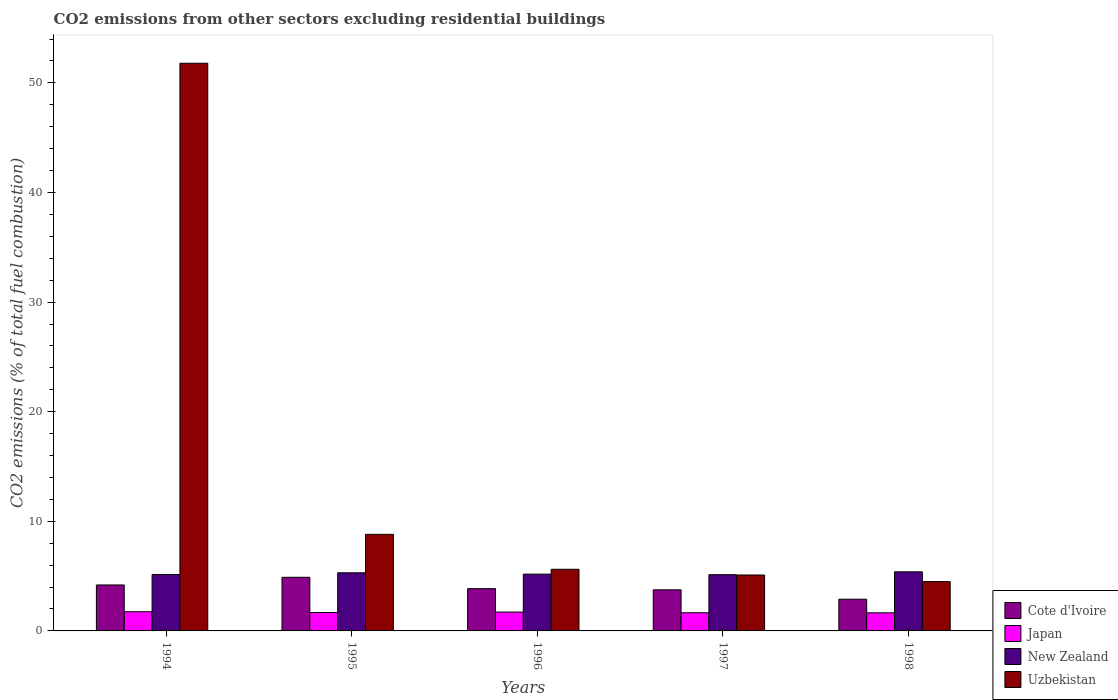How many groups of bars are there?
Give a very brief answer. 5. What is the label of the 1st group of bars from the left?
Your answer should be compact. 1994. What is the total CO2 emitted in Japan in 1995?
Offer a terse response. 1.68. Across all years, what is the maximum total CO2 emitted in Japan?
Offer a terse response. 1.75. Across all years, what is the minimum total CO2 emitted in Cote d'Ivoire?
Your response must be concise. 2.89. In which year was the total CO2 emitted in Japan maximum?
Offer a very short reply. 1994. What is the total total CO2 emitted in Cote d'Ivoire in the graph?
Make the answer very short. 19.59. What is the difference between the total CO2 emitted in Cote d'Ivoire in 1996 and that in 1997?
Your answer should be compact. 0.11. What is the difference between the total CO2 emitted in Cote d'Ivoire in 1998 and the total CO2 emitted in New Zealand in 1995?
Your answer should be very brief. -2.41. What is the average total CO2 emitted in Cote d'Ivoire per year?
Provide a short and direct response. 3.92. In the year 1994, what is the difference between the total CO2 emitted in New Zealand and total CO2 emitted in Uzbekistan?
Give a very brief answer. -46.64. In how many years, is the total CO2 emitted in New Zealand greater than 8?
Provide a succinct answer. 0. What is the ratio of the total CO2 emitted in New Zealand in 1994 to that in 1997?
Offer a terse response. 1. Is the difference between the total CO2 emitted in New Zealand in 1994 and 1998 greater than the difference between the total CO2 emitted in Uzbekistan in 1994 and 1998?
Keep it short and to the point. No. What is the difference between the highest and the second highest total CO2 emitted in Uzbekistan?
Keep it short and to the point. 42.98. What is the difference between the highest and the lowest total CO2 emitted in Japan?
Provide a succinct answer. 0.1. In how many years, is the total CO2 emitted in Cote d'Ivoire greater than the average total CO2 emitted in Cote d'Ivoire taken over all years?
Give a very brief answer. 2. Is the sum of the total CO2 emitted in New Zealand in 1994 and 1995 greater than the maximum total CO2 emitted in Cote d'Ivoire across all years?
Your answer should be compact. Yes. Is it the case that in every year, the sum of the total CO2 emitted in Japan and total CO2 emitted in New Zealand is greater than the sum of total CO2 emitted in Uzbekistan and total CO2 emitted in Cote d'Ivoire?
Your answer should be very brief. No. What does the 4th bar from the left in 1998 represents?
Your answer should be compact. Uzbekistan. What does the 1st bar from the right in 1994 represents?
Offer a terse response. Uzbekistan. Is it the case that in every year, the sum of the total CO2 emitted in Cote d'Ivoire and total CO2 emitted in Japan is greater than the total CO2 emitted in Uzbekistan?
Ensure brevity in your answer.  No. Are all the bars in the graph horizontal?
Make the answer very short. No. What is the difference between two consecutive major ticks on the Y-axis?
Offer a terse response. 10. Does the graph contain any zero values?
Provide a succinct answer. No. What is the title of the graph?
Provide a short and direct response. CO2 emissions from other sectors excluding residential buildings. Does "Sub-Saharan Africa (developing only)" appear as one of the legend labels in the graph?
Your answer should be compact. No. What is the label or title of the X-axis?
Offer a terse response. Years. What is the label or title of the Y-axis?
Offer a very short reply. CO2 emissions (% of total fuel combustion). What is the CO2 emissions (% of total fuel combustion) of Cote d'Ivoire in 1994?
Make the answer very short. 4.19. What is the CO2 emissions (% of total fuel combustion) in Japan in 1994?
Your response must be concise. 1.75. What is the CO2 emissions (% of total fuel combustion) in New Zealand in 1994?
Provide a succinct answer. 5.15. What is the CO2 emissions (% of total fuel combustion) of Uzbekistan in 1994?
Give a very brief answer. 51.79. What is the CO2 emissions (% of total fuel combustion) of Cote d'Ivoire in 1995?
Your answer should be very brief. 4.89. What is the CO2 emissions (% of total fuel combustion) of Japan in 1995?
Ensure brevity in your answer.  1.68. What is the CO2 emissions (% of total fuel combustion) in New Zealand in 1995?
Ensure brevity in your answer.  5.3. What is the CO2 emissions (% of total fuel combustion) in Uzbekistan in 1995?
Offer a very short reply. 8.81. What is the CO2 emissions (% of total fuel combustion) of Cote d'Ivoire in 1996?
Keep it short and to the point. 3.86. What is the CO2 emissions (% of total fuel combustion) of Japan in 1996?
Your response must be concise. 1.72. What is the CO2 emissions (% of total fuel combustion) of New Zealand in 1996?
Provide a short and direct response. 5.18. What is the CO2 emissions (% of total fuel combustion) in Uzbekistan in 1996?
Your response must be concise. 5.62. What is the CO2 emissions (% of total fuel combustion) in Cote d'Ivoire in 1997?
Your response must be concise. 3.75. What is the CO2 emissions (% of total fuel combustion) in Japan in 1997?
Provide a succinct answer. 1.66. What is the CO2 emissions (% of total fuel combustion) of New Zealand in 1997?
Give a very brief answer. 5.13. What is the CO2 emissions (% of total fuel combustion) of Uzbekistan in 1997?
Make the answer very short. 5.1. What is the CO2 emissions (% of total fuel combustion) in Cote d'Ivoire in 1998?
Your answer should be compact. 2.89. What is the CO2 emissions (% of total fuel combustion) in Japan in 1998?
Keep it short and to the point. 1.65. What is the CO2 emissions (% of total fuel combustion) of New Zealand in 1998?
Your answer should be very brief. 5.39. What is the CO2 emissions (% of total fuel combustion) of Uzbekistan in 1998?
Give a very brief answer. 4.5. Across all years, what is the maximum CO2 emissions (% of total fuel combustion) in Cote d'Ivoire?
Provide a short and direct response. 4.89. Across all years, what is the maximum CO2 emissions (% of total fuel combustion) in Japan?
Your answer should be very brief. 1.75. Across all years, what is the maximum CO2 emissions (% of total fuel combustion) of New Zealand?
Give a very brief answer. 5.39. Across all years, what is the maximum CO2 emissions (% of total fuel combustion) of Uzbekistan?
Provide a succinct answer. 51.79. Across all years, what is the minimum CO2 emissions (% of total fuel combustion) of Cote d'Ivoire?
Your response must be concise. 2.89. Across all years, what is the minimum CO2 emissions (% of total fuel combustion) in Japan?
Keep it short and to the point. 1.65. Across all years, what is the minimum CO2 emissions (% of total fuel combustion) in New Zealand?
Ensure brevity in your answer.  5.13. Across all years, what is the minimum CO2 emissions (% of total fuel combustion) in Uzbekistan?
Make the answer very short. 4.5. What is the total CO2 emissions (% of total fuel combustion) of Cote d'Ivoire in the graph?
Your response must be concise. 19.59. What is the total CO2 emissions (% of total fuel combustion) of Japan in the graph?
Your response must be concise. 8.45. What is the total CO2 emissions (% of total fuel combustion) in New Zealand in the graph?
Your response must be concise. 26.15. What is the total CO2 emissions (% of total fuel combustion) of Uzbekistan in the graph?
Keep it short and to the point. 75.82. What is the difference between the CO2 emissions (% of total fuel combustion) in Cote d'Ivoire in 1994 and that in 1995?
Ensure brevity in your answer.  -0.7. What is the difference between the CO2 emissions (% of total fuel combustion) in Japan in 1994 and that in 1995?
Offer a very short reply. 0.07. What is the difference between the CO2 emissions (% of total fuel combustion) in New Zealand in 1994 and that in 1995?
Give a very brief answer. -0.15. What is the difference between the CO2 emissions (% of total fuel combustion) in Uzbekistan in 1994 and that in 1995?
Your answer should be very brief. 42.98. What is the difference between the CO2 emissions (% of total fuel combustion) of Cote d'Ivoire in 1994 and that in 1996?
Make the answer very short. 0.34. What is the difference between the CO2 emissions (% of total fuel combustion) in Japan in 1994 and that in 1996?
Offer a terse response. 0.03. What is the difference between the CO2 emissions (% of total fuel combustion) of New Zealand in 1994 and that in 1996?
Ensure brevity in your answer.  -0.03. What is the difference between the CO2 emissions (% of total fuel combustion) in Uzbekistan in 1994 and that in 1996?
Your answer should be very brief. 46.16. What is the difference between the CO2 emissions (% of total fuel combustion) in Cote d'Ivoire in 1994 and that in 1997?
Ensure brevity in your answer.  0.44. What is the difference between the CO2 emissions (% of total fuel combustion) of Japan in 1994 and that in 1997?
Offer a terse response. 0.09. What is the difference between the CO2 emissions (% of total fuel combustion) in New Zealand in 1994 and that in 1997?
Offer a very short reply. 0.02. What is the difference between the CO2 emissions (% of total fuel combustion) in Uzbekistan in 1994 and that in 1997?
Your answer should be very brief. 46.69. What is the difference between the CO2 emissions (% of total fuel combustion) in Cote d'Ivoire in 1994 and that in 1998?
Make the answer very short. 1.3. What is the difference between the CO2 emissions (% of total fuel combustion) in Japan in 1994 and that in 1998?
Make the answer very short. 0.1. What is the difference between the CO2 emissions (% of total fuel combustion) of New Zealand in 1994 and that in 1998?
Make the answer very short. -0.24. What is the difference between the CO2 emissions (% of total fuel combustion) in Uzbekistan in 1994 and that in 1998?
Ensure brevity in your answer.  47.29. What is the difference between the CO2 emissions (% of total fuel combustion) of Cote d'Ivoire in 1995 and that in 1996?
Your answer should be compact. 1.04. What is the difference between the CO2 emissions (% of total fuel combustion) of Japan in 1995 and that in 1996?
Give a very brief answer. -0.04. What is the difference between the CO2 emissions (% of total fuel combustion) in New Zealand in 1995 and that in 1996?
Offer a very short reply. 0.12. What is the difference between the CO2 emissions (% of total fuel combustion) in Uzbekistan in 1995 and that in 1996?
Your answer should be compact. 3.19. What is the difference between the CO2 emissions (% of total fuel combustion) of Cote d'Ivoire in 1995 and that in 1997?
Offer a terse response. 1.14. What is the difference between the CO2 emissions (% of total fuel combustion) of Japan in 1995 and that in 1997?
Your answer should be compact. 0.02. What is the difference between the CO2 emissions (% of total fuel combustion) in New Zealand in 1995 and that in 1997?
Keep it short and to the point. 0.17. What is the difference between the CO2 emissions (% of total fuel combustion) of Uzbekistan in 1995 and that in 1997?
Make the answer very short. 3.71. What is the difference between the CO2 emissions (% of total fuel combustion) in Cote d'Ivoire in 1995 and that in 1998?
Your answer should be very brief. 2. What is the difference between the CO2 emissions (% of total fuel combustion) of Japan in 1995 and that in 1998?
Your answer should be compact. 0.03. What is the difference between the CO2 emissions (% of total fuel combustion) in New Zealand in 1995 and that in 1998?
Offer a terse response. -0.09. What is the difference between the CO2 emissions (% of total fuel combustion) of Uzbekistan in 1995 and that in 1998?
Your answer should be very brief. 4.31. What is the difference between the CO2 emissions (% of total fuel combustion) of Cote d'Ivoire in 1996 and that in 1997?
Provide a succinct answer. 0.11. What is the difference between the CO2 emissions (% of total fuel combustion) in Japan in 1996 and that in 1997?
Your response must be concise. 0.06. What is the difference between the CO2 emissions (% of total fuel combustion) in New Zealand in 1996 and that in 1997?
Ensure brevity in your answer.  0.05. What is the difference between the CO2 emissions (% of total fuel combustion) in Uzbekistan in 1996 and that in 1997?
Make the answer very short. 0.52. What is the difference between the CO2 emissions (% of total fuel combustion) of Cote d'Ivoire in 1996 and that in 1998?
Your response must be concise. 0.96. What is the difference between the CO2 emissions (% of total fuel combustion) of Japan in 1996 and that in 1998?
Make the answer very short. 0.07. What is the difference between the CO2 emissions (% of total fuel combustion) in New Zealand in 1996 and that in 1998?
Ensure brevity in your answer.  -0.21. What is the difference between the CO2 emissions (% of total fuel combustion) of Uzbekistan in 1996 and that in 1998?
Provide a short and direct response. 1.12. What is the difference between the CO2 emissions (% of total fuel combustion) of Cote d'Ivoire in 1997 and that in 1998?
Provide a short and direct response. 0.86. What is the difference between the CO2 emissions (% of total fuel combustion) in Japan in 1997 and that in 1998?
Your response must be concise. 0. What is the difference between the CO2 emissions (% of total fuel combustion) of New Zealand in 1997 and that in 1998?
Your answer should be compact. -0.26. What is the difference between the CO2 emissions (% of total fuel combustion) in Uzbekistan in 1997 and that in 1998?
Keep it short and to the point. 0.6. What is the difference between the CO2 emissions (% of total fuel combustion) of Cote d'Ivoire in 1994 and the CO2 emissions (% of total fuel combustion) of Japan in 1995?
Provide a short and direct response. 2.52. What is the difference between the CO2 emissions (% of total fuel combustion) in Cote d'Ivoire in 1994 and the CO2 emissions (% of total fuel combustion) in New Zealand in 1995?
Your response must be concise. -1.11. What is the difference between the CO2 emissions (% of total fuel combustion) in Cote d'Ivoire in 1994 and the CO2 emissions (% of total fuel combustion) in Uzbekistan in 1995?
Ensure brevity in your answer.  -4.62. What is the difference between the CO2 emissions (% of total fuel combustion) in Japan in 1994 and the CO2 emissions (% of total fuel combustion) in New Zealand in 1995?
Your response must be concise. -3.55. What is the difference between the CO2 emissions (% of total fuel combustion) in Japan in 1994 and the CO2 emissions (% of total fuel combustion) in Uzbekistan in 1995?
Give a very brief answer. -7.06. What is the difference between the CO2 emissions (% of total fuel combustion) of New Zealand in 1994 and the CO2 emissions (% of total fuel combustion) of Uzbekistan in 1995?
Offer a very short reply. -3.66. What is the difference between the CO2 emissions (% of total fuel combustion) in Cote d'Ivoire in 1994 and the CO2 emissions (% of total fuel combustion) in Japan in 1996?
Your answer should be compact. 2.48. What is the difference between the CO2 emissions (% of total fuel combustion) in Cote d'Ivoire in 1994 and the CO2 emissions (% of total fuel combustion) in New Zealand in 1996?
Make the answer very short. -0.99. What is the difference between the CO2 emissions (% of total fuel combustion) in Cote d'Ivoire in 1994 and the CO2 emissions (% of total fuel combustion) in Uzbekistan in 1996?
Offer a very short reply. -1.43. What is the difference between the CO2 emissions (% of total fuel combustion) of Japan in 1994 and the CO2 emissions (% of total fuel combustion) of New Zealand in 1996?
Give a very brief answer. -3.43. What is the difference between the CO2 emissions (% of total fuel combustion) in Japan in 1994 and the CO2 emissions (% of total fuel combustion) in Uzbekistan in 1996?
Your answer should be compact. -3.87. What is the difference between the CO2 emissions (% of total fuel combustion) of New Zealand in 1994 and the CO2 emissions (% of total fuel combustion) of Uzbekistan in 1996?
Make the answer very short. -0.47. What is the difference between the CO2 emissions (% of total fuel combustion) in Cote d'Ivoire in 1994 and the CO2 emissions (% of total fuel combustion) in Japan in 1997?
Provide a short and direct response. 2.54. What is the difference between the CO2 emissions (% of total fuel combustion) in Cote d'Ivoire in 1994 and the CO2 emissions (% of total fuel combustion) in New Zealand in 1997?
Keep it short and to the point. -0.94. What is the difference between the CO2 emissions (% of total fuel combustion) in Cote d'Ivoire in 1994 and the CO2 emissions (% of total fuel combustion) in Uzbekistan in 1997?
Make the answer very short. -0.91. What is the difference between the CO2 emissions (% of total fuel combustion) of Japan in 1994 and the CO2 emissions (% of total fuel combustion) of New Zealand in 1997?
Give a very brief answer. -3.38. What is the difference between the CO2 emissions (% of total fuel combustion) of Japan in 1994 and the CO2 emissions (% of total fuel combustion) of Uzbekistan in 1997?
Provide a succinct answer. -3.35. What is the difference between the CO2 emissions (% of total fuel combustion) of New Zealand in 1994 and the CO2 emissions (% of total fuel combustion) of Uzbekistan in 1997?
Keep it short and to the point. 0.05. What is the difference between the CO2 emissions (% of total fuel combustion) in Cote d'Ivoire in 1994 and the CO2 emissions (% of total fuel combustion) in Japan in 1998?
Your answer should be very brief. 2.54. What is the difference between the CO2 emissions (% of total fuel combustion) of Cote d'Ivoire in 1994 and the CO2 emissions (% of total fuel combustion) of New Zealand in 1998?
Keep it short and to the point. -1.2. What is the difference between the CO2 emissions (% of total fuel combustion) of Cote d'Ivoire in 1994 and the CO2 emissions (% of total fuel combustion) of Uzbekistan in 1998?
Ensure brevity in your answer.  -0.31. What is the difference between the CO2 emissions (% of total fuel combustion) of Japan in 1994 and the CO2 emissions (% of total fuel combustion) of New Zealand in 1998?
Provide a succinct answer. -3.64. What is the difference between the CO2 emissions (% of total fuel combustion) in Japan in 1994 and the CO2 emissions (% of total fuel combustion) in Uzbekistan in 1998?
Provide a succinct answer. -2.75. What is the difference between the CO2 emissions (% of total fuel combustion) in New Zealand in 1994 and the CO2 emissions (% of total fuel combustion) in Uzbekistan in 1998?
Your answer should be compact. 0.65. What is the difference between the CO2 emissions (% of total fuel combustion) of Cote d'Ivoire in 1995 and the CO2 emissions (% of total fuel combustion) of Japan in 1996?
Make the answer very short. 3.17. What is the difference between the CO2 emissions (% of total fuel combustion) of Cote d'Ivoire in 1995 and the CO2 emissions (% of total fuel combustion) of New Zealand in 1996?
Provide a succinct answer. -0.29. What is the difference between the CO2 emissions (% of total fuel combustion) of Cote d'Ivoire in 1995 and the CO2 emissions (% of total fuel combustion) of Uzbekistan in 1996?
Ensure brevity in your answer.  -0.73. What is the difference between the CO2 emissions (% of total fuel combustion) in Japan in 1995 and the CO2 emissions (% of total fuel combustion) in New Zealand in 1996?
Your response must be concise. -3.5. What is the difference between the CO2 emissions (% of total fuel combustion) of Japan in 1995 and the CO2 emissions (% of total fuel combustion) of Uzbekistan in 1996?
Your answer should be very brief. -3.95. What is the difference between the CO2 emissions (% of total fuel combustion) in New Zealand in 1995 and the CO2 emissions (% of total fuel combustion) in Uzbekistan in 1996?
Make the answer very short. -0.32. What is the difference between the CO2 emissions (% of total fuel combustion) in Cote d'Ivoire in 1995 and the CO2 emissions (% of total fuel combustion) in Japan in 1997?
Your response must be concise. 3.24. What is the difference between the CO2 emissions (% of total fuel combustion) in Cote d'Ivoire in 1995 and the CO2 emissions (% of total fuel combustion) in New Zealand in 1997?
Ensure brevity in your answer.  -0.24. What is the difference between the CO2 emissions (% of total fuel combustion) of Cote d'Ivoire in 1995 and the CO2 emissions (% of total fuel combustion) of Uzbekistan in 1997?
Offer a terse response. -0.21. What is the difference between the CO2 emissions (% of total fuel combustion) in Japan in 1995 and the CO2 emissions (% of total fuel combustion) in New Zealand in 1997?
Your answer should be compact. -3.45. What is the difference between the CO2 emissions (% of total fuel combustion) in Japan in 1995 and the CO2 emissions (% of total fuel combustion) in Uzbekistan in 1997?
Offer a terse response. -3.43. What is the difference between the CO2 emissions (% of total fuel combustion) of New Zealand in 1995 and the CO2 emissions (% of total fuel combustion) of Uzbekistan in 1997?
Keep it short and to the point. 0.2. What is the difference between the CO2 emissions (% of total fuel combustion) in Cote d'Ivoire in 1995 and the CO2 emissions (% of total fuel combustion) in Japan in 1998?
Keep it short and to the point. 3.24. What is the difference between the CO2 emissions (% of total fuel combustion) in Cote d'Ivoire in 1995 and the CO2 emissions (% of total fuel combustion) in New Zealand in 1998?
Offer a terse response. -0.5. What is the difference between the CO2 emissions (% of total fuel combustion) in Cote d'Ivoire in 1995 and the CO2 emissions (% of total fuel combustion) in Uzbekistan in 1998?
Your answer should be compact. 0.39. What is the difference between the CO2 emissions (% of total fuel combustion) in Japan in 1995 and the CO2 emissions (% of total fuel combustion) in New Zealand in 1998?
Give a very brief answer. -3.72. What is the difference between the CO2 emissions (% of total fuel combustion) in Japan in 1995 and the CO2 emissions (% of total fuel combustion) in Uzbekistan in 1998?
Give a very brief answer. -2.82. What is the difference between the CO2 emissions (% of total fuel combustion) in New Zealand in 1995 and the CO2 emissions (% of total fuel combustion) in Uzbekistan in 1998?
Ensure brevity in your answer.  0.8. What is the difference between the CO2 emissions (% of total fuel combustion) of Cote d'Ivoire in 1996 and the CO2 emissions (% of total fuel combustion) of New Zealand in 1997?
Provide a short and direct response. -1.27. What is the difference between the CO2 emissions (% of total fuel combustion) in Cote d'Ivoire in 1996 and the CO2 emissions (% of total fuel combustion) in Uzbekistan in 1997?
Provide a short and direct response. -1.25. What is the difference between the CO2 emissions (% of total fuel combustion) in Japan in 1996 and the CO2 emissions (% of total fuel combustion) in New Zealand in 1997?
Offer a very short reply. -3.41. What is the difference between the CO2 emissions (% of total fuel combustion) in Japan in 1996 and the CO2 emissions (% of total fuel combustion) in Uzbekistan in 1997?
Ensure brevity in your answer.  -3.38. What is the difference between the CO2 emissions (% of total fuel combustion) in New Zealand in 1996 and the CO2 emissions (% of total fuel combustion) in Uzbekistan in 1997?
Your answer should be compact. 0.08. What is the difference between the CO2 emissions (% of total fuel combustion) in Cote d'Ivoire in 1996 and the CO2 emissions (% of total fuel combustion) in Japan in 1998?
Your answer should be compact. 2.2. What is the difference between the CO2 emissions (% of total fuel combustion) in Cote d'Ivoire in 1996 and the CO2 emissions (% of total fuel combustion) in New Zealand in 1998?
Provide a succinct answer. -1.54. What is the difference between the CO2 emissions (% of total fuel combustion) of Cote d'Ivoire in 1996 and the CO2 emissions (% of total fuel combustion) of Uzbekistan in 1998?
Your answer should be very brief. -0.64. What is the difference between the CO2 emissions (% of total fuel combustion) of Japan in 1996 and the CO2 emissions (% of total fuel combustion) of New Zealand in 1998?
Make the answer very short. -3.67. What is the difference between the CO2 emissions (% of total fuel combustion) in Japan in 1996 and the CO2 emissions (% of total fuel combustion) in Uzbekistan in 1998?
Your response must be concise. -2.78. What is the difference between the CO2 emissions (% of total fuel combustion) of New Zealand in 1996 and the CO2 emissions (% of total fuel combustion) of Uzbekistan in 1998?
Give a very brief answer. 0.68. What is the difference between the CO2 emissions (% of total fuel combustion) of Cote d'Ivoire in 1997 and the CO2 emissions (% of total fuel combustion) of Japan in 1998?
Make the answer very short. 2.1. What is the difference between the CO2 emissions (% of total fuel combustion) in Cote d'Ivoire in 1997 and the CO2 emissions (% of total fuel combustion) in New Zealand in 1998?
Offer a very short reply. -1.64. What is the difference between the CO2 emissions (% of total fuel combustion) in Cote d'Ivoire in 1997 and the CO2 emissions (% of total fuel combustion) in Uzbekistan in 1998?
Give a very brief answer. -0.75. What is the difference between the CO2 emissions (% of total fuel combustion) in Japan in 1997 and the CO2 emissions (% of total fuel combustion) in New Zealand in 1998?
Provide a succinct answer. -3.74. What is the difference between the CO2 emissions (% of total fuel combustion) in Japan in 1997 and the CO2 emissions (% of total fuel combustion) in Uzbekistan in 1998?
Your answer should be compact. -2.84. What is the difference between the CO2 emissions (% of total fuel combustion) of New Zealand in 1997 and the CO2 emissions (% of total fuel combustion) of Uzbekistan in 1998?
Keep it short and to the point. 0.63. What is the average CO2 emissions (% of total fuel combustion) in Cote d'Ivoire per year?
Make the answer very short. 3.92. What is the average CO2 emissions (% of total fuel combustion) of Japan per year?
Your response must be concise. 1.69. What is the average CO2 emissions (% of total fuel combustion) of New Zealand per year?
Give a very brief answer. 5.23. What is the average CO2 emissions (% of total fuel combustion) in Uzbekistan per year?
Your response must be concise. 15.16. In the year 1994, what is the difference between the CO2 emissions (% of total fuel combustion) in Cote d'Ivoire and CO2 emissions (% of total fuel combustion) in Japan?
Make the answer very short. 2.45. In the year 1994, what is the difference between the CO2 emissions (% of total fuel combustion) of Cote d'Ivoire and CO2 emissions (% of total fuel combustion) of New Zealand?
Give a very brief answer. -0.96. In the year 1994, what is the difference between the CO2 emissions (% of total fuel combustion) of Cote d'Ivoire and CO2 emissions (% of total fuel combustion) of Uzbekistan?
Provide a succinct answer. -47.59. In the year 1994, what is the difference between the CO2 emissions (% of total fuel combustion) in Japan and CO2 emissions (% of total fuel combustion) in New Zealand?
Make the answer very short. -3.4. In the year 1994, what is the difference between the CO2 emissions (% of total fuel combustion) in Japan and CO2 emissions (% of total fuel combustion) in Uzbekistan?
Provide a short and direct response. -50.04. In the year 1994, what is the difference between the CO2 emissions (% of total fuel combustion) in New Zealand and CO2 emissions (% of total fuel combustion) in Uzbekistan?
Give a very brief answer. -46.64. In the year 1995, what is the difference between the CO2 emissions (% of total fuel combustion) of Cote d'Ivoire and CO2 emissions (% of total fuel combustion) of Japan?
Provide a succinct answer. 3.22. In the year 1995, what is the difference between the CO2 emissions (% of total fuel combustion) of Cote d'Ivoire and CO2 emissions (% of total fuel combustion) of New Zealand?
Provide a succinct answer. -0.41. In the year 1995, what is the difference between the CO2 emissions (% of total fuel combustion) in Cote d'Ivoire and CO2 emissions (% of total fuel combustion) in Uzbekistan?
Your answer should be compact. -3.92. In the year 1995, what is the difference between the CO2 emissions (% of total fuel combustion) in Japan and CO2 emissions (% of total fuel combustion) in New Zealand?
Keep it short and to the point. -3.63. In the year 1995, what is the difference between the CO2 emissions (% of total fuel combustion) in Japan and CO2 emissions (% of total fuel combustion) in Uzbekistan?
Provide a short and direct response. -7.13. In the year 1995, what is the difference between the CO2 emissions (% of total fuel combustion) in New Zealand and CO2 emissions (% of total fuel combustion) in Uzbekistan?
Ensure brevity in your answer.  -3.51. In the year 1996, what is the difference between the CO2 emissions (% of total fuel combustion) in Cote d'Ivoire and CO2 emissions (% of total fuel combustion) in Japan?
Give a very brief answer. 2.14. In the year 1996, what is the difference between the CO2 emissions (% of total fuel combustion) of Cote d'Ivoire and CO2 emissions (% of total fuel combustion) of New Zealand?
Keep it short and to the point. -1.32. In the year 1996, what is the difference between the CO2 emissions (% of total fuel combustion) in Cote d'Ivoire and CO2 emissions (% of total fuel combustion) in Uzbekistan?
Provide a succinct answer. -1.77. In the year 1996, what is the difference between the CO2 emissions (% of total fuel combustion) in Japan and CO2 emissions (% of total fuel combustion) in New Zealand?
Keep it short and to the point. -3.46. In the year 1996, what is the difference between the CO2 emissions (% of total fuel combustion) in Japan and CO2 emissions (% of total fuel combustion) in Uzbekistan?
Your response must be concise. -3.9. In the year 1996, what is the difference between the CO2 emissions (% of total fuel combustion) in New Zealand and CO2 emissions (% of total fuel combustion) in Uzbekistan?
Give a very brief answer. -0.44. In the year 1997, what is the difference between the CO2 emissions (% of total fuel combustion) of Cote d'Ivoire and CO2 emissions (% of total fuel combustion) of Japan?
Offer a very short reply. 2.09. In the year 1997, what is the difference between the CO2 emissions (% of total fuel combustion) of Cote d'Ivoire and CO2 emissions (% of total fuel combustion) of New Zealand?
Your response must be concise. -1.38. In the year 1997, what is the difference between the CO2 emissions (% of total fuel combustion) of Cote d'Ivoire and CO2 emissions (% of total fuel combustion) of Uzbekistan?
Ensure brevity in your answer.  -1.35. In the year 1997, what is the difference between the CO2 emissions (% of total fuel combustion) in Japan and CO2 emissions (% of total fuel combustion) in New Zealand?
Keep it short and to the point. -3.47. In the year 1997, what is the difference between the CO2 emissions (% of total fuel combustion) of Japan and CO2 emissions (% of total fuel combustion) of Uzbekistan?
Offer a terse response. -3.45. In the year 1997, what is the difference between the CO2 emissions (% of total fuel combustion) in New Zealand and CO2 emissions (% of total fuel combustion) in Uzbekistan?
Your response must be concise. 0.03. In the year 1998, what is the difference between the CO2 emissions (% of total fuel combustion) in Cote d'Ivoire and CO2 emissions (% of total fuel combustion) in Japan?
Your answer should be very brief. 1.24. In the year 1998, what is the difference between the CO2 emissions (% of total fuel combustion) of Cote d'Ivoire and CO2 emissions (% of total fuel combustion) of New Zealand?
Offer a terse response. -2.5. In the year 1998, what is the difference between the CO2 emissions (% of total fuel combustion) in Cote d'Ivoire and CO2 emissions (% of total fuel combustion) in Uzbekistan?
Your answer should be compact. -1.61. In the year 1998, what is the difference between the CO2 emissions (% of total fuel combustion) in Japan and CO2 emissions (% of total fuel combustion) in New Zealand?
Provide a succinct answer. -3.74. In the year 1998, what is the difference between the CO2 emissions (% of total fuel combustion) of Japan and CO2 emissions (% of total fuel combustion) of Uzbekistan?
Ensure brevity in your answer.  -2.85. In the year 1998, what is the difference between the CO2 emissions (% of total fuel combustion) of New Zealand and CO2 emissions (% of total fuel combustion) of Uzbekistan?
Your response must be concise. 0.89. What is the ratio of the CO2 emissions (% of total fuel combustion) in Cote d'Ivoire in 1994 to that in 1995?
Offer a very short reply. 0.86. What is the ratio of the CO2 emissions (% of total fuel combustion) in Japan in 1994 to that in 1995?
Offer a terse response. 1.04. What is the ratio of the CO2 emissions (% of total fuel combustion) of New Zealand in 1994 to that in 1995?
Offer a very short reply. 0.97. What is the ratio of the CO2 emissions (% of total fuel combustion) of Uzbekistan in 1994 to that in 1995?
Ensure brevity in your answer.  5.88. What is the ratio of the CO2 emissions (% of total fuel combustion) in Cote d'Ivoire in 1994 to that in 1996?
Ensure brevity in your answer.  1.09. What is the ratio of the CO2 emissions (% of total fuel combustion) of Japan in 1994 to that in 1996?
Make the answer very short. 1.02. What is the ratio of the CO2 emissions (% of total fuel combustion) of New Zealand in 1994 to that in 1996?
Make the answer very short. 0.99. What is the ratio of the CO2 emissions (% of total fuel combustion) of Uzbekistan in 1994 to that in 1996?
Your answer should be very brief. 9.21. What is the ratio of the CO2 emissions (% of total fuel combustion) in Cote d'Ivoire in 1994 to that in 1997?
Give a very brief answer. 1.12. What is the ratio of the CO2 emissions (% of total fuel combustion) in Japan in 1994 to that in 1997?
Your response must be concise. 1.06. What is the ratio of the CO2 emissions (% of total fuel combustion) in Uzbekistan in 1994 to that in 1997?
Your answer should be very brief. 10.15. What is the ratio of the CO2 emissions (% of total fuel combustion) in Cote d'Ivoire in 1994 to that in 1998?
Your answer should be compact. 1.45. What is the ratio of the CO2 emissions (% of total fuel combustion) in Japan in 1994 to that in 1998?
Ensure brevity in your answer.  1.06. What is the ratio of the CO2 emissions (% of total fuel combustion) in New Zealand in 1994 to that in 1998?
Give a very brief answer. 0.96. What is the ratio of the CO2 emissions (% of total fuel combustion) of Uzbekistan in 1994 to that in 1998?
Your response must be concise. 11.51. What is the ratio of the CO2 emissions (% of total fuel combustion) of Cote d'Ivoire in 1995 to that in 1996?
Give a very brief answer. 1.27. What is the ratio of the CO2 emissions (% of total fuel combustion) in Japan in 1995 to that in 1996?
Provide a succinct answer. 0.98. What is the ratio of the CO2 emissions (% of total fuel combustion) in New Zealand in 1995 to that in 1996?
Offer a very short reply. 1.02. What is the ratio of the CO2 emissions (% of total fuel combustion) in Uzbekistan in 1995 to that in 1996?
Your answer should be very brief. 1.57. What is the ratio of the CO2 emissions (% of total fuel combustion) of Cote d'Ivoire in 1995 to that in 1997?
Ensure brevity in your answer.  1.3. What is the ratio of the CO2 emissions (% of total fuel combustion) in Japan in 1995 to that in 1997?
Your answer should be very brief. 1.01. What is the ratio of the CO2 emissions (% of total fuel combustion) of New Zealand in 1995 to that in 1997?
Your answer should be very brief. 1.03. What is the ratio of the CO2 emissions (% of total fuel combustion) of Uzbekistan in 1995 to that in 1997?
Ensure brevity in your answer.  1.73. What is the ratio of the CO2 emissions (% of total fuel combustion) in Cote d'Ivoire in 1995 to that in 1998?
Keep it short and to the point. 1.69. What is the ratio of the CO2 emissions (% of total fuel combustion) of Japan in 1995 to that in 1998?
Your answer should be compact. 1.02. What is the ratio of the CO2 emissions (% of total fuel combustion) of New Zealand in 1995 to that in 1998?
Ensure brevity in your answer.  0.98. What is the ratio of the CO2 emissions (% of total fuel combustion) of Uzbekistan in 1995 to that in 1998?
Your response must be concise. 1.96. What is the ratio of the CO2 emissions (% of total fuel combustion) in Cote d'Ivoire in 1996 to that in 1997?
Your response must be concise. 1.03. What is the ratio of the CO2 emissions (% of total fuel combustion) in Japan in 1996 to that in 1997?
Give a very brief answer. 1.04. What is the ratio of the CO2 emissions (% of total fuel combustion) in New Zealand in 1996 to that in 1997?
Your answer should be compact. 1.01. What is the ratio of the CO2 emissions (% of total fuel combustion) of Uzbekistan in 1996 to that in 1997?
Keep it short and to the point. 1.1. What is the ratio of the CO2 emissions (% of total fuel combustion) in Cote d'Ivoire in 1996 to that in 1998?
Your answer should be very brief. 1.33. What is the ratio of the CO2 emissions (% of total fuel combustion) in Japan in 1996 to that in 1998?
Make the answer very short. 1.04. What is the ratio of the CO2 emissions (% of total fuel combustion) in New Zealand in 1996 to that in 1998?
Ensure brevity in your answer.  0.96. What is the ratio of the CO2 emissions (% of total fuel combustion) in Uzbekistan in 1996 to that in 1998?
Keep it short and to the point. 1.25. What is the ratio of the CO2 emissions (% of total fuel combustion) of Cote d'Ivoire in 1997 to that in 1998?
Give a very brief answer. 1.3. What is the ratio of the CO2 emissions (% of total fuel combustion) in Japan in 1997 to that in 1998?
Make the answer very short. 1. What is the ratio of the CO2 emissions (% of total fuel combustion) of New Zealand in 1997 to that in 1998?
Provide a succinct answer. 0.95. What is the ratio of the CO2 emissions (% of total fuel combustion) in Uzbekistan in 1997 to that in 1998?
Provide a short and direct response. 1.13. What is the difference between the highest and the second highest CO2 emissions (% of total fuel combustion) in Cote d'Ivoire?
Your answer should be compact. 0.7. What is the difference between the highest and the second highest CO2 emissions (% of total fuel combustion) in Japan?
Your answer should be compact. 0.03. What is the difference between the highest and the second highest CO2 emissions (% of total fuel combustion) in New Zealand?
Provide a succinct answer. 0.09. What is the difference between the highest and the second highest CO2 emissions (% of total fuel combustion) of Uzbekistan?
Provide a short and direct response. 42.98. What is the difference between the highest and the lowest CO2 emissions (% of total fuel combustion) of Cote d'Ivoire?
Provide a short and direct response. 2. What is the difference between the highest and the lowest CO2 emissions (% of total fuel combustion) of Japan?
Ensure brevity in your answer.  0.1. What is the difference between the highest and the lowest CO2 emissions (% of total fuel combustion) in New Zealand?
Your response must be concise. 0.26. What is the difference between the highest and the lowest CO2 emissions (% of total fuel combustion) in Uzbekistan?
Offer a terse response. 47.29. 